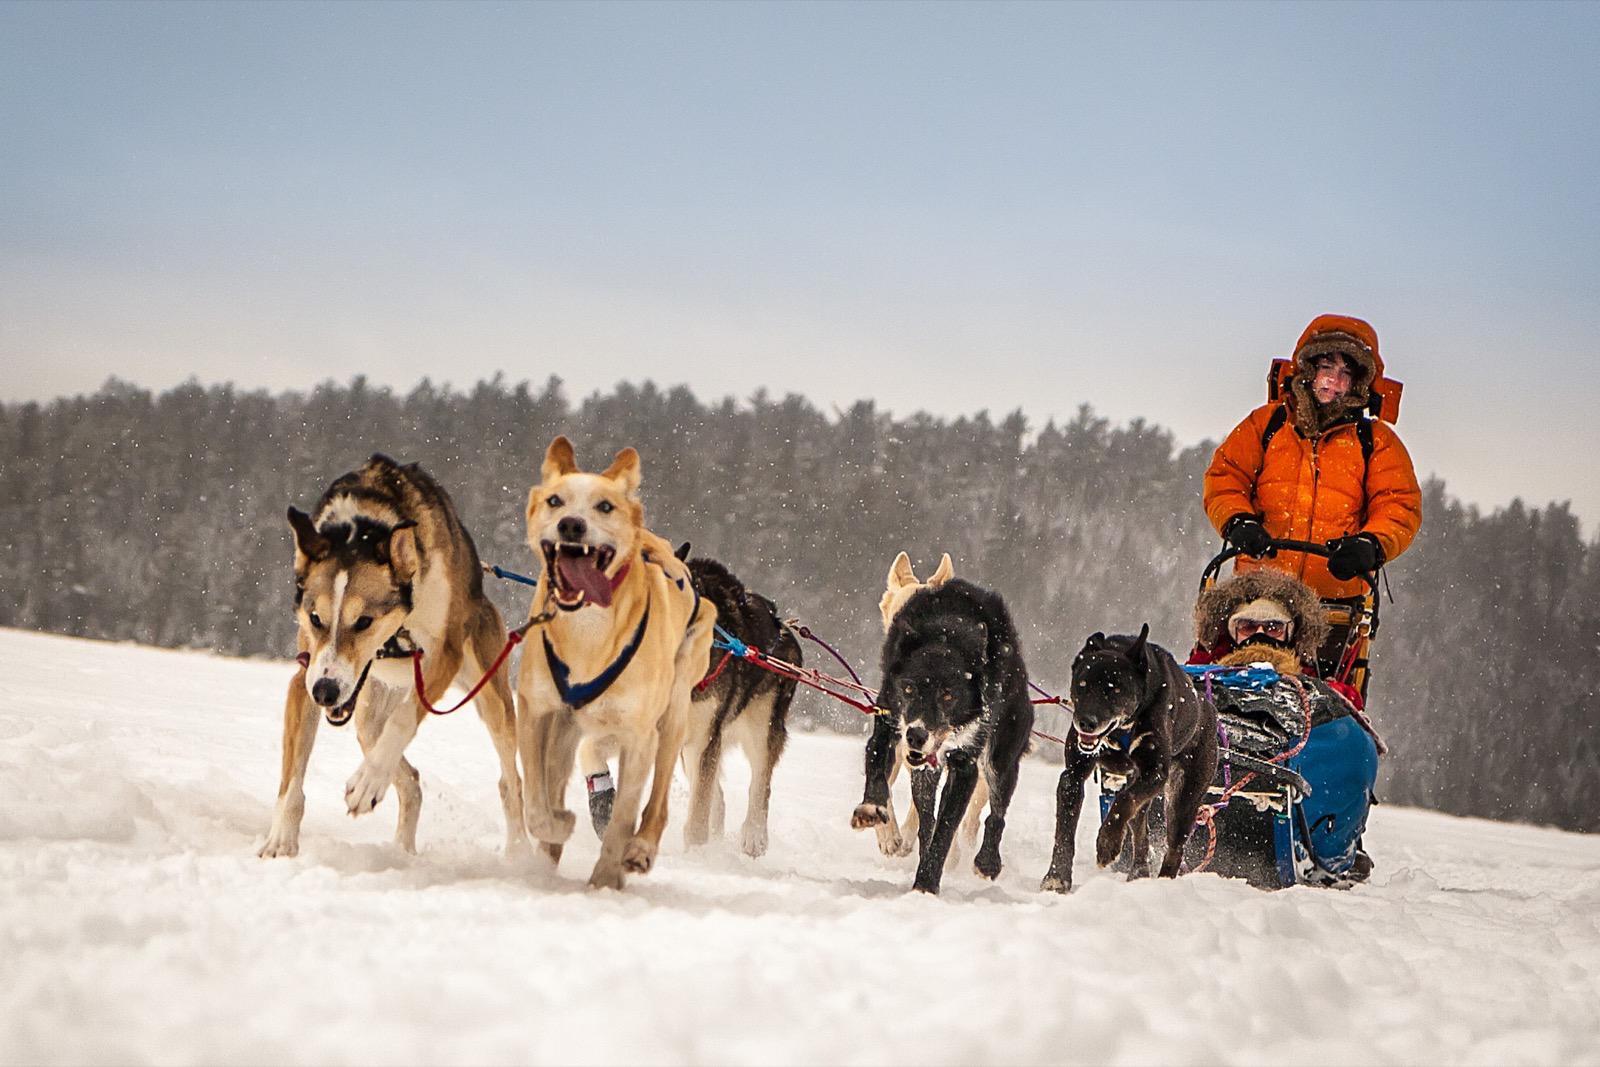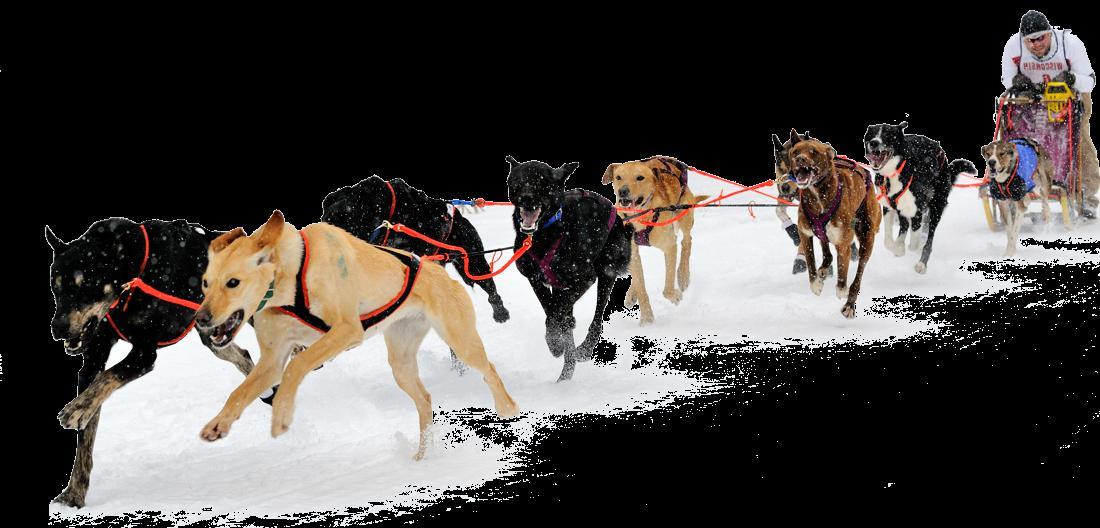The first image is the image on the left, the second image is the image on the right. Assess this claim about the two images: "Right image shows a team of harnessed dogs heading leftward, with a line of trees in the background.". Correct or not? Answer yes or no. No. The first image is the image on the left, the second image is the image on the right. Given the left and right images, does the statement "The dogs are pulling a sled with a person wearing orange in one of the images." hold true? Answer yes or no. Yes. 